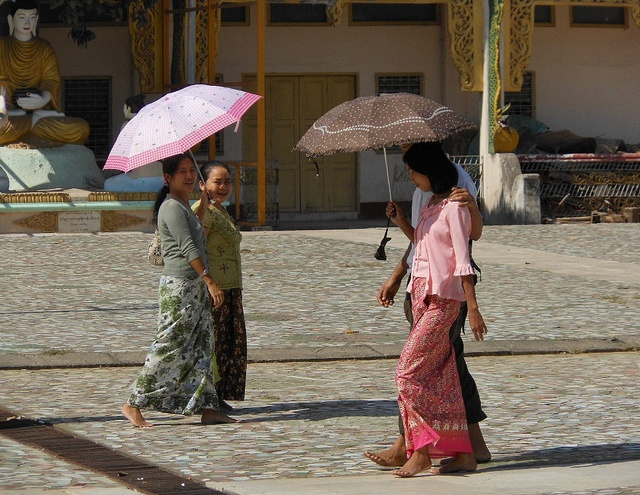Describe the objects in this image and their specific colors. I can see people in black, maroon, brown, and lightpink tones, people in black, gray, and darkgray tones, umbrella in black and gray tones, people in black, darkgreen, maroon, and gray tones, and umbrella in black, lavender, lightpink, pink, and violet tones in this image. 